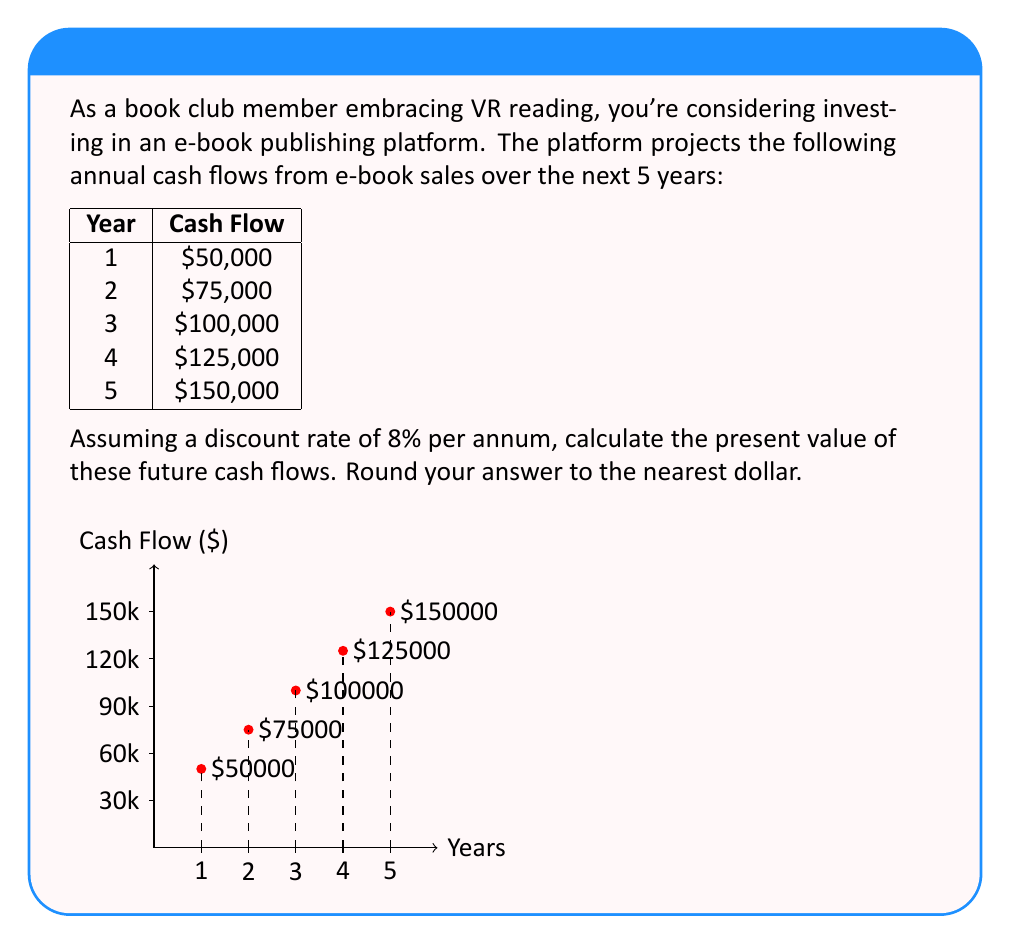Can you solve this math problem? To calculate the present value of future cash flows, we need to discount each cash flow back to the present using the given discount rate. The formula for present value is:

$$PV = \frac{CF_t}{(1+r)^t}$$

Where:
$PV$ = Present Value
$CF_t$ = Cash Flow at time t
$r$ = Discount rate
$t$ = Time period

Let's calculate the present value for each year:

Year 1: $PV_1 = \frac{50,000}{(1+0.08)^1} = 46,296.30$

Year 2: $PV_2 = \frac{75,000}{(1+0.08)^2} = 64,300.54$

Year 3: $PV_3 = \frac{100,000}{(1+0.08)^3} = 79,383.47$

Year 4: $PV_4 = \frac{125,000}{(1+0.08)^4} = 91,983.81$

Year 5: $PV_5 = \frac{150,000}{(1+0.08)^5} = 102,204.24$

Now, we sum up all these present values:

$Total PV = 46,296.30 + 64,300.54 + 79,383.47 + 91,983.81 + 102,204.24 = 384,168.36$

Rounding to the nearest dollar, we get $384,168.
Answer: $384,168 